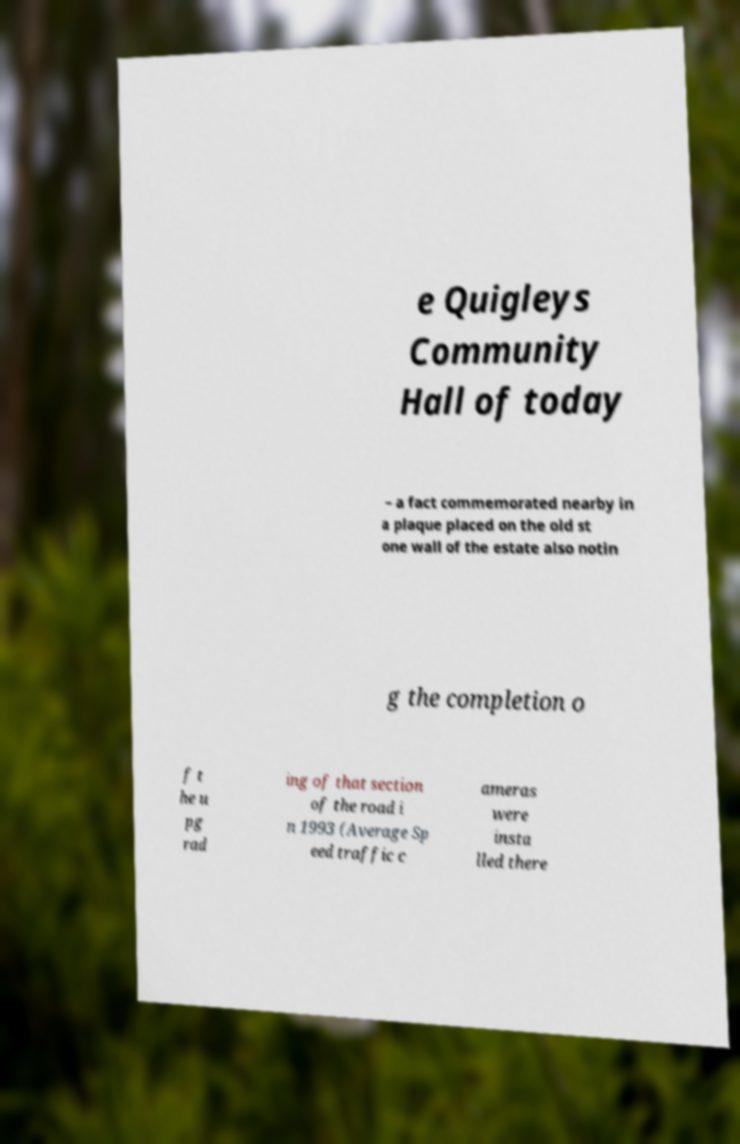There's text embedded in this image that I need extracted. Can you transcribe it verbatim? e Quigleys Community Hall of today – a fact commemorated nearby in a plaque placed on the old st one wall of the estate also notin g the completion o f t he u pg rad ing of that section of the road i n 1993 (Average Sp eed traffic c ameras were insta lled there 